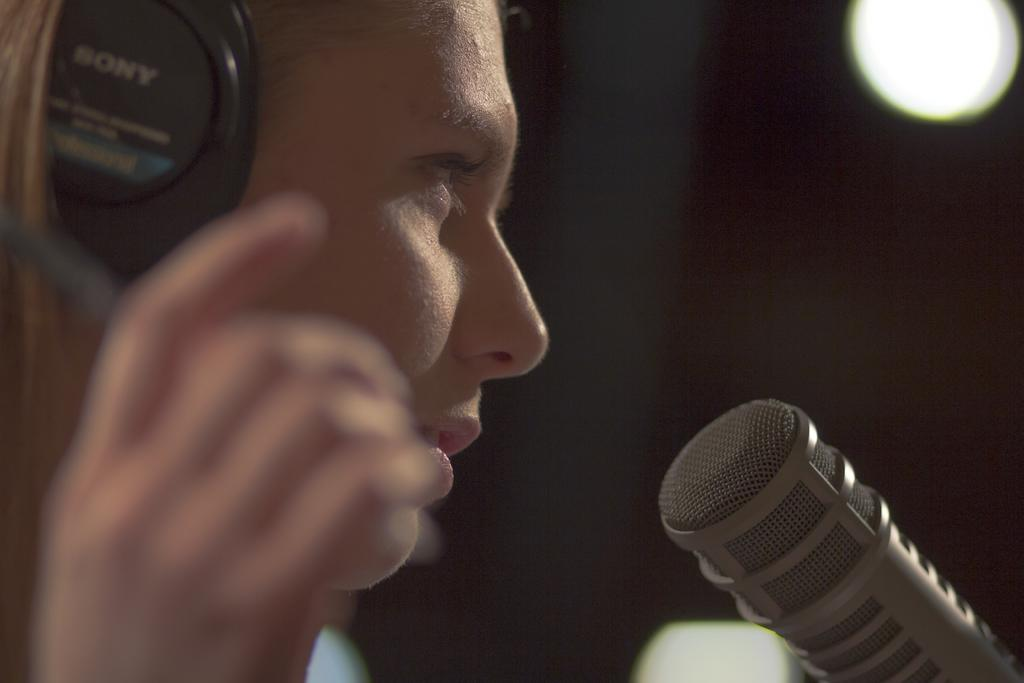What is the main subject of the image? There is a person in the image. What can be seen on the person's head? The person is wearing headphones. What object is in front of the person? There is a microphone in front of the person. What can be seen in the background of the image? There is a light in the background of the image. How does the person's grandmother react to the burst of laughter in the image? There is no grandmother or burst of laughter present in the image. 